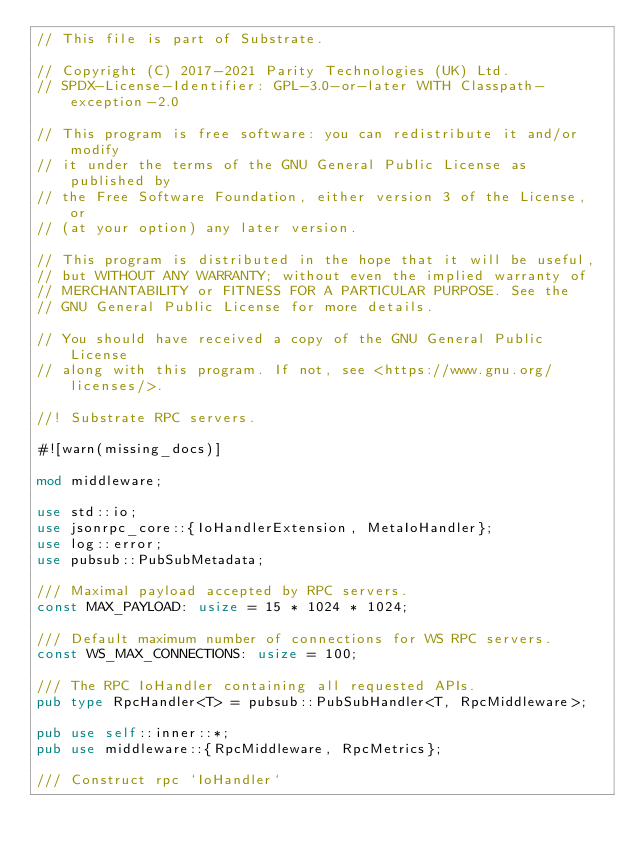Convert code to text. <code><loc_0><loc_0><loc_500><loc_500><_Rust_>// This file is part of Substrate.

// Copyright (C) 2017-2021 Parity Technologies (UK) Ltd.
// SPDX-License-Identifier: GPL-3.0-or-later WITH Classpath-exception-2.0

// This program is free software: you can redistribute it and/or modify
// it under the terms of the GNU General Public License as published by
// the Free Software Foundation, either version 3 of the License, or
// (at your option) any later version.

// This program is distributed in the hope that it will be useful,
// but WITHOUT ANY WARRANTY; without even the implied warranty of
// MERCHANTABILITY or FITNESS FOR A PARTICULAR PURPOSE. See the
// GNU General Public License for more details.

// You should have received a copy of the GNU General Public License
// along with this program. If not, see <https://www.gnu.org/licenses/>.

//! Substrate RPC servers.

#![warn(missing_docs)]

mod middleware;

use std::io;
use jsonrpc_core::{IoHandlerExtension, MetaIoHandler};
use log::error;
use pubsub::PubSubMetadata;

/// Maximal payload accepted by RPC servers.
const MAX_PAYLOAD: usize = 15 * 1024 * 1024;

/// Default maximum number of connections for WS RPC servers.
const WS_MAX_CONNECTIONS: usize = 100;

/// The RPC IoHandler containing all requested APIs.
pub type RpcHandler<T> = pubsub::PubSubHandler<T, RpcMiddleware>;

pub use self::inner::*;
pub use middleware::{RpcMiddleware, RpcMetrics};

/// Construct rpc `IoHandler`</code> 